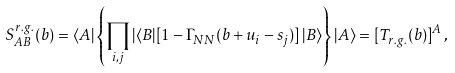<formula> <loc_0><loc_0><loc_500><loc_500>S _ { A B } ^ { r . g . } ( b ) = \langle A | \left \{ \prod _ { i , j } | \langle B | [ 1 - \Gamma _ { N N } ( b + u _ { i } - s _ { j } ) ] \, | B \rangle \right \} | A \rangle = [ T _ { r . g . } ( b ) ] ^ { A } \, ,</formula> 